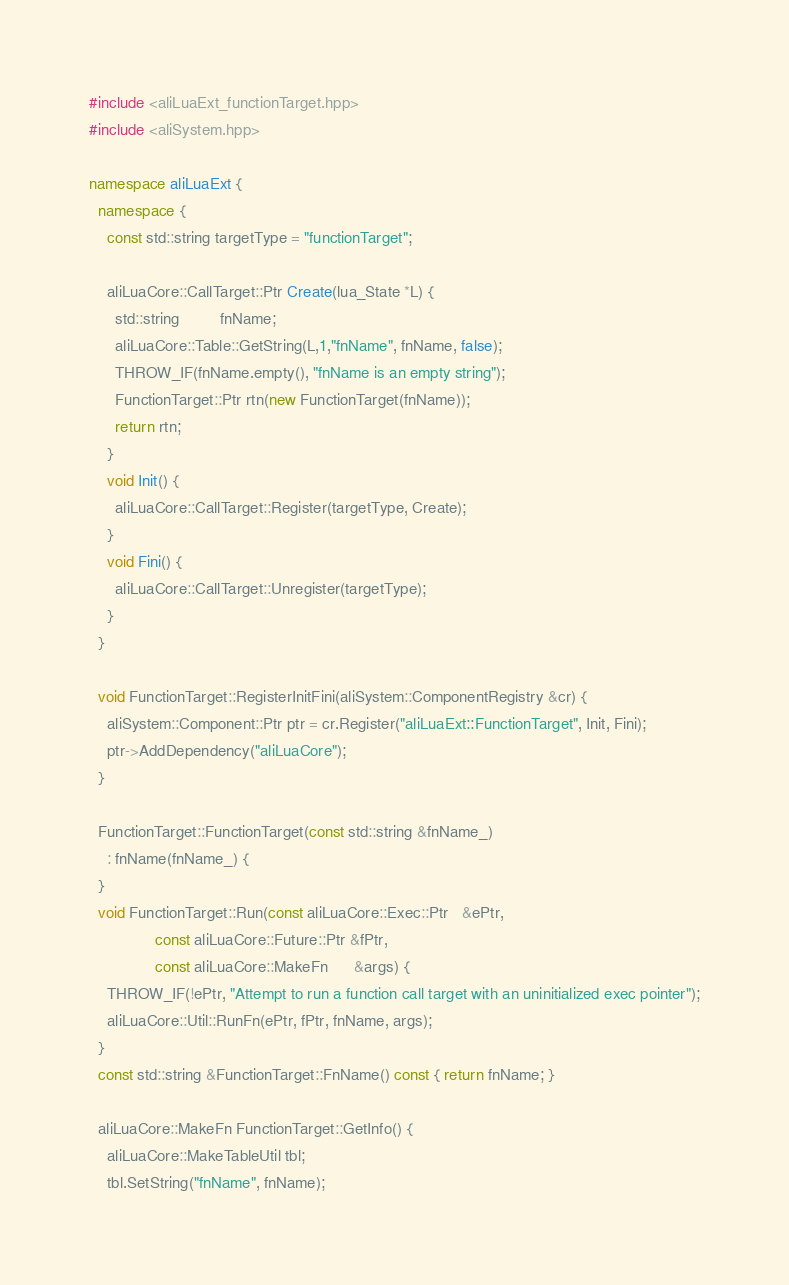<code> <loc_0><loc_0><loc_500><loc_500><_C++_>#include <aliLuaExt_functionTarget.hpp>
#include <aliSystem.hpp>

namespace aliLuaExt {
  namespace {
    const std::string targetType = "functionTarget";

    aliLuaCore::CallTarget::Ptr Create(lua_State *L) {
      std::string         fnName;
      aliLuaCore::Table::GetString(L,1,"fnName", fnName, false);
      THROW_IF(fnName.empty(), "fnName is an empty string");
      FunctionTarget::Ptr rtn(new FunctionTarget(fnName));
      return rtn;
    }
    void Init() {
      aliLuaCore::CallTarget::Register(targetType, Create);
    }
    void Fini() {
      aliLuaCore::CallTarget::Unregister(targetType);
    }
  }

  void FunctionTarget::RegisterInitFini(aliSystem::ComponentRegistry &cr) {
    aliSystem::Component::Ptr ptr = cr.Register("aliLuaExt::FunctionTarget", Init, Fini);
    ptr->AddDependency("aliLuaCore");
  }
  
  FunctionTarget::FunctionTarget(const std::string &fnName_)
    : fnName(fnName_) {
  }
  void FunctionTarget::Run(const aliLuaCore::Exec::Ptr   &ePtr,
			   const aliLuaCore::Future::Ptr &fPtr,
			   const aliLuaCore::MakeFn      &args) {
    THROW_IF(!ePtr, "Attempt to run a function call target with an uninitialized exec pointer");
    aliLuaCore::Util::RunFn(ePtr, fPtr, fnName, args);
  }
  const std::string &FunctionTarget::FnName() const { return fnName; }

  aliLuaCore::MakeFn FunctionTarget::GetInfo() {
    aliLuaCore::MakeTableUtil tbl;
    tbl.SetString("fnName", fnName);</code> 